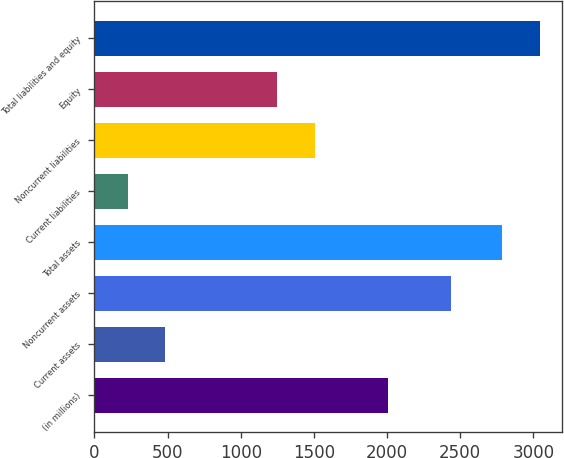Convert chart. <chart><loc_0><loc_0><loc_500><loc_500><bar_chart><fcel>(in millions)<fcel>Current assets<fcel>Noncurrent assets<fcel>Total assets<fcel>Current liabilities<fcel>Noncurrent liabilities<fcel>Equity<fcel>Total liabilities and equity<nl><fcel>2010<fcel>483.2<fcel>2437<fcel>2789<fcel>227<fcel>1506.2<fcel>1250<fcel>3045.2<nl></chart> 